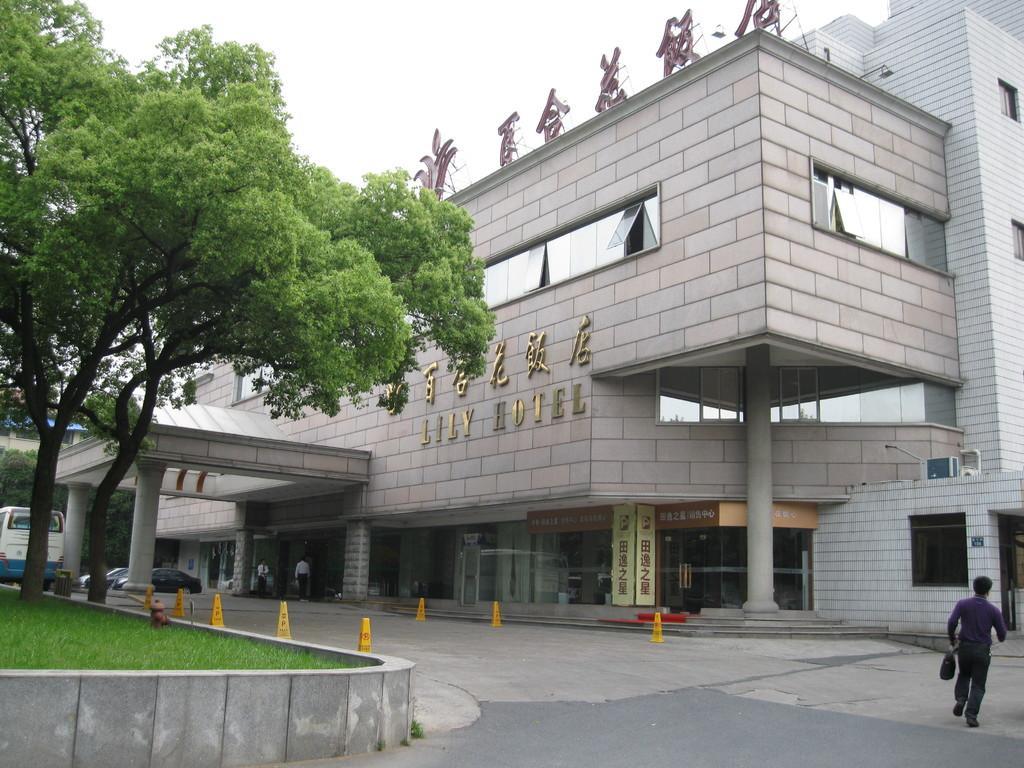How would you summarize this image in a sentence or two? In this image there is a building in front of that there are vehicles parked behind that there are some divider cones and also there is a tree, person walking on the road. 